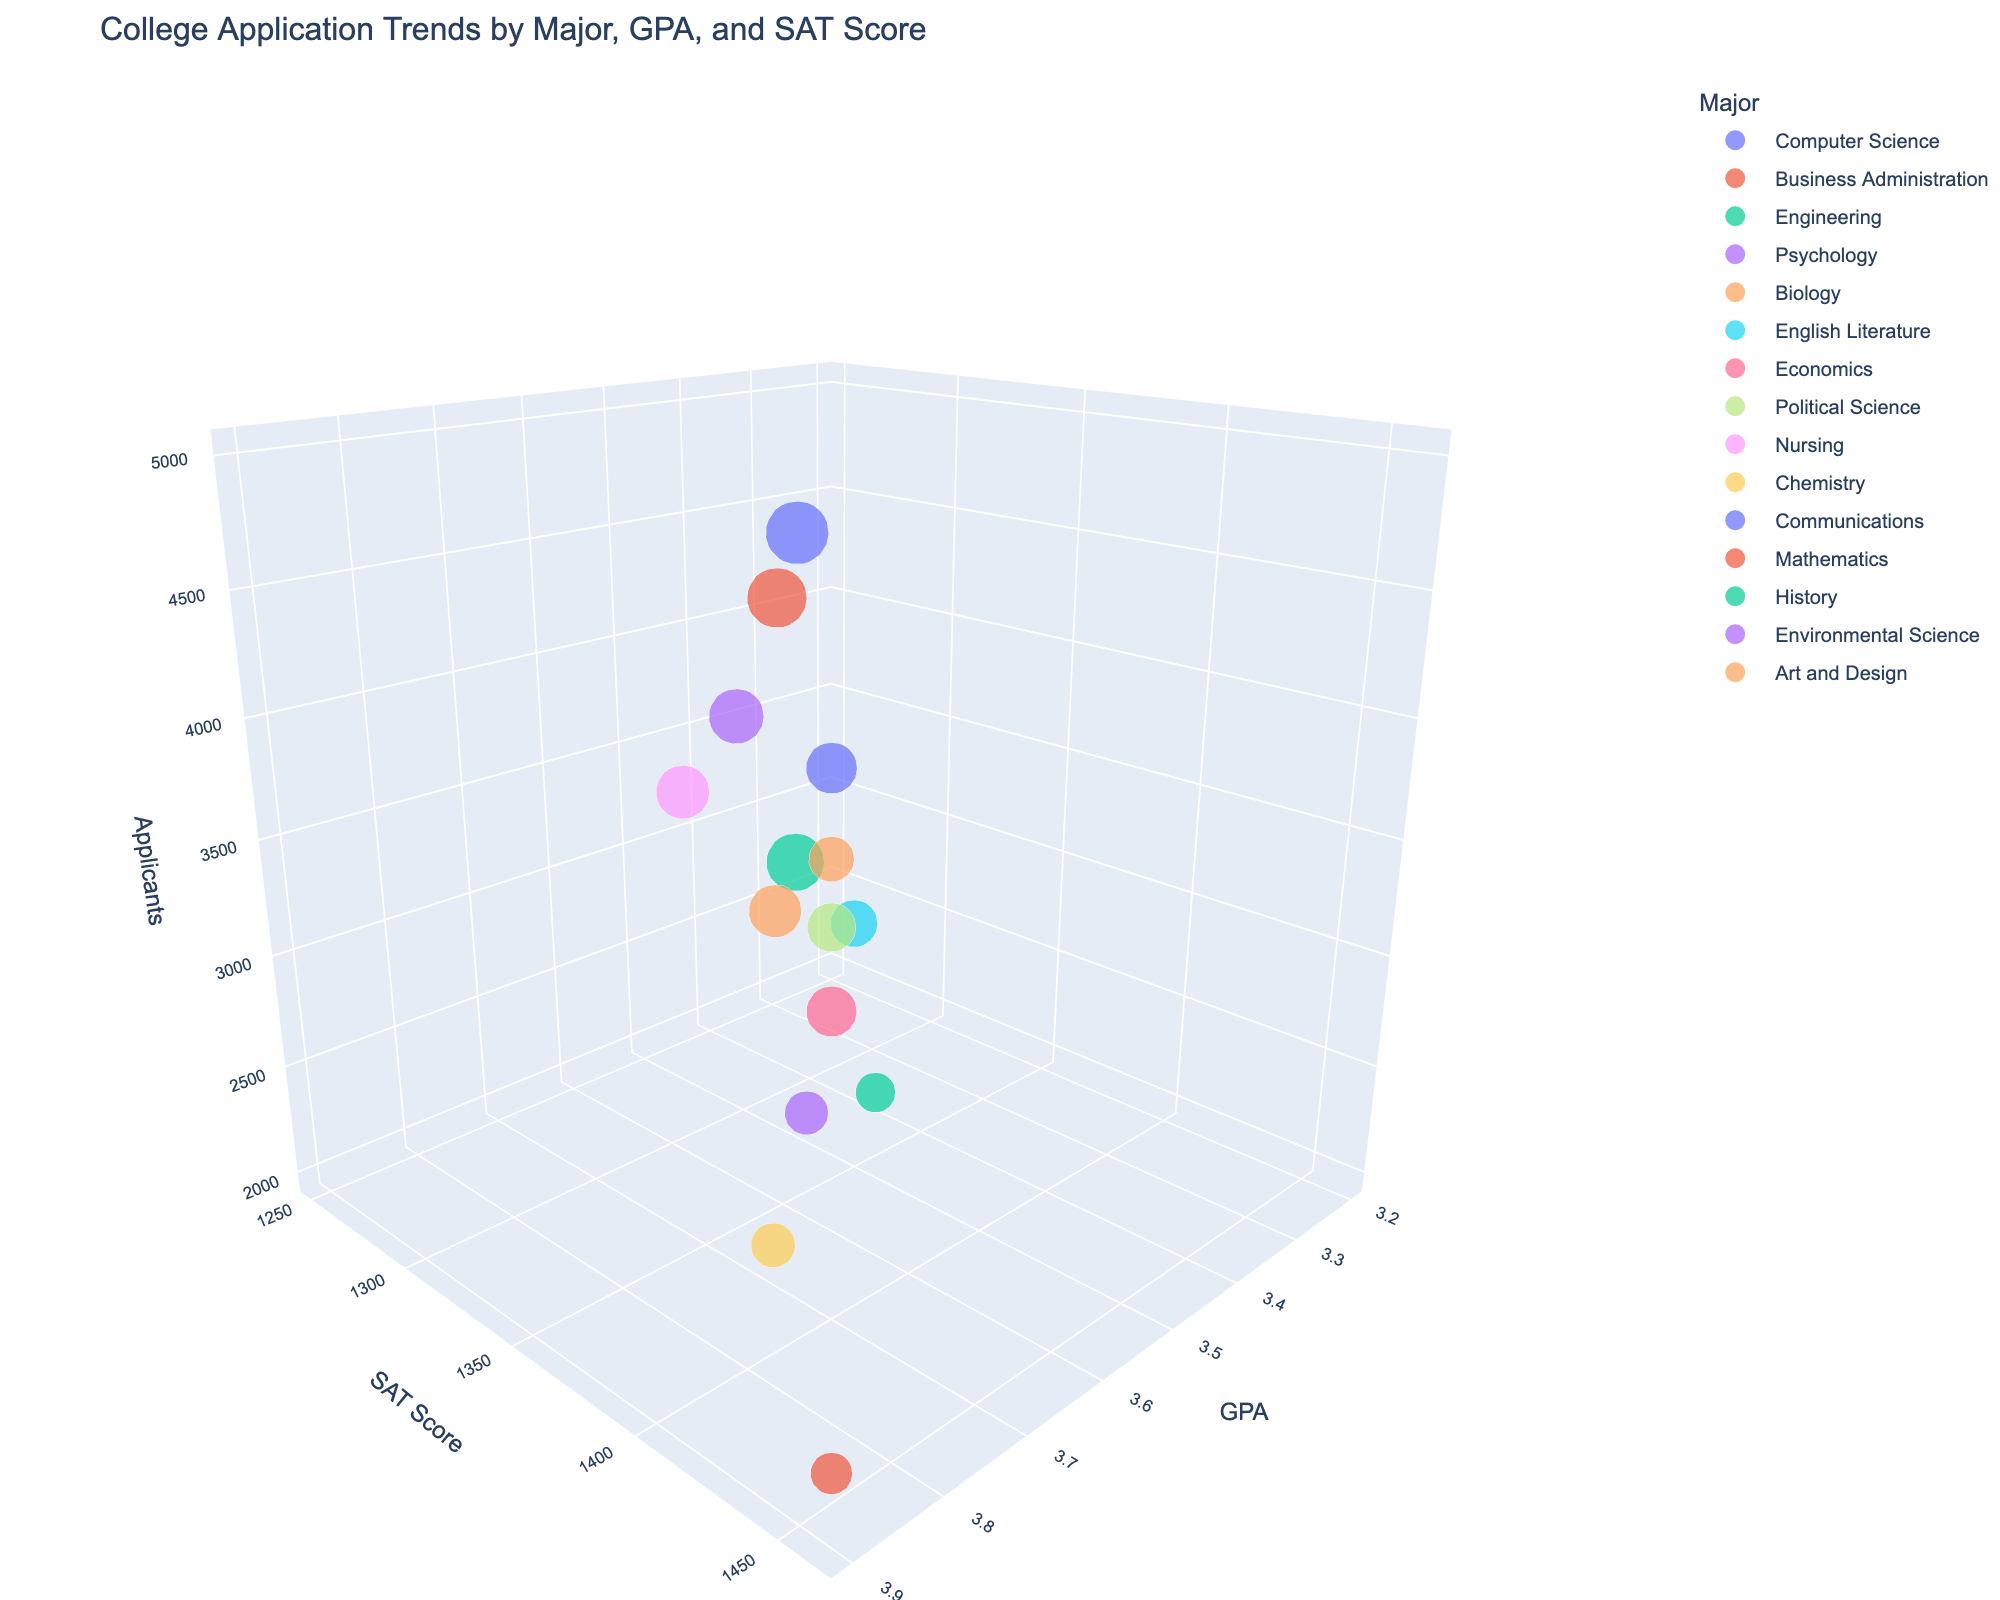How many majors are shown in the chart? Count the number of distinct bubbles representing different majors in the 3D bubble chart.
Answer: 15 What is the title of the chart? Look at the top part of the figure for the main title.
Answer: College Application Trends by Major, GPA, and SAT Score Which major has the highest average GPA and what is it? Identify the bubble located at the highest position on the GPA axis.
Answer: Engineering, 3.9 Which major has the highest average SAT score and what is it? Identify the bubble located at the highest position on the SAT Score axis.
Answer: Mathematics, 1460 What is the number of applicants for the major with the lowest average GPA? First determine which bubble corresponds to the lowest position on the GPA axis, then look at its size and the value of the number of applicants for that major.
Answer: Art and Design, 2600 Which major has the least number of applicants and what is the count? Identify the bubble that appears smallest (size representing the number of applicants) and note its applicant count.
Answer: History, 2000 Compare the average GPA for Computer Science and Political Science. Which one is higher? Locate the bubbles for Computer Science and Political Science on the GPA axis and compare their positions.
Answer: Computer Science Between Business Administration and Nursing, which has a higher average SAT score and by how much? Locate the bubbles for Business Administration and Nursing on the SAT Score axis and calculate the difference between their positions.
Answer: Business Administration, higher by 40 points What is the average number of applicants across all majors? Sum the number of applicants for all majors, then divide by the number of majors.
Answer: 3186.7 (rounded) Which major has a higher average GPA than Economics but also a lower average SAT score than Engineering? Find all majors with a GPA greater than Economics (3.7) and an SAT score lower than Engineering (1450), then identify the one meeting both conditions.
Answer: Nursing 